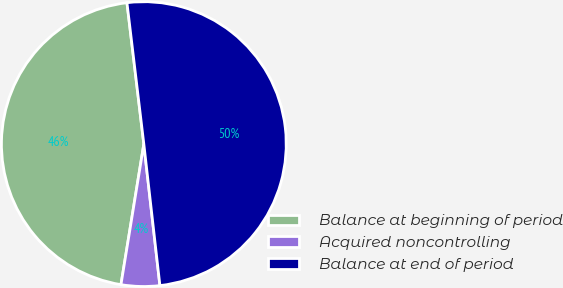Convert chart to OTSL. <chart><loc_0><loc_0><loc_500><loc_500><pie_chart><fcel>Balance at beginning of period<fcel>Acquired noncontrolling<fcel>Balance at end of period<nl><fcel>45.54%<fcel>4.37%<fcel>50.09%<nl></chart> 